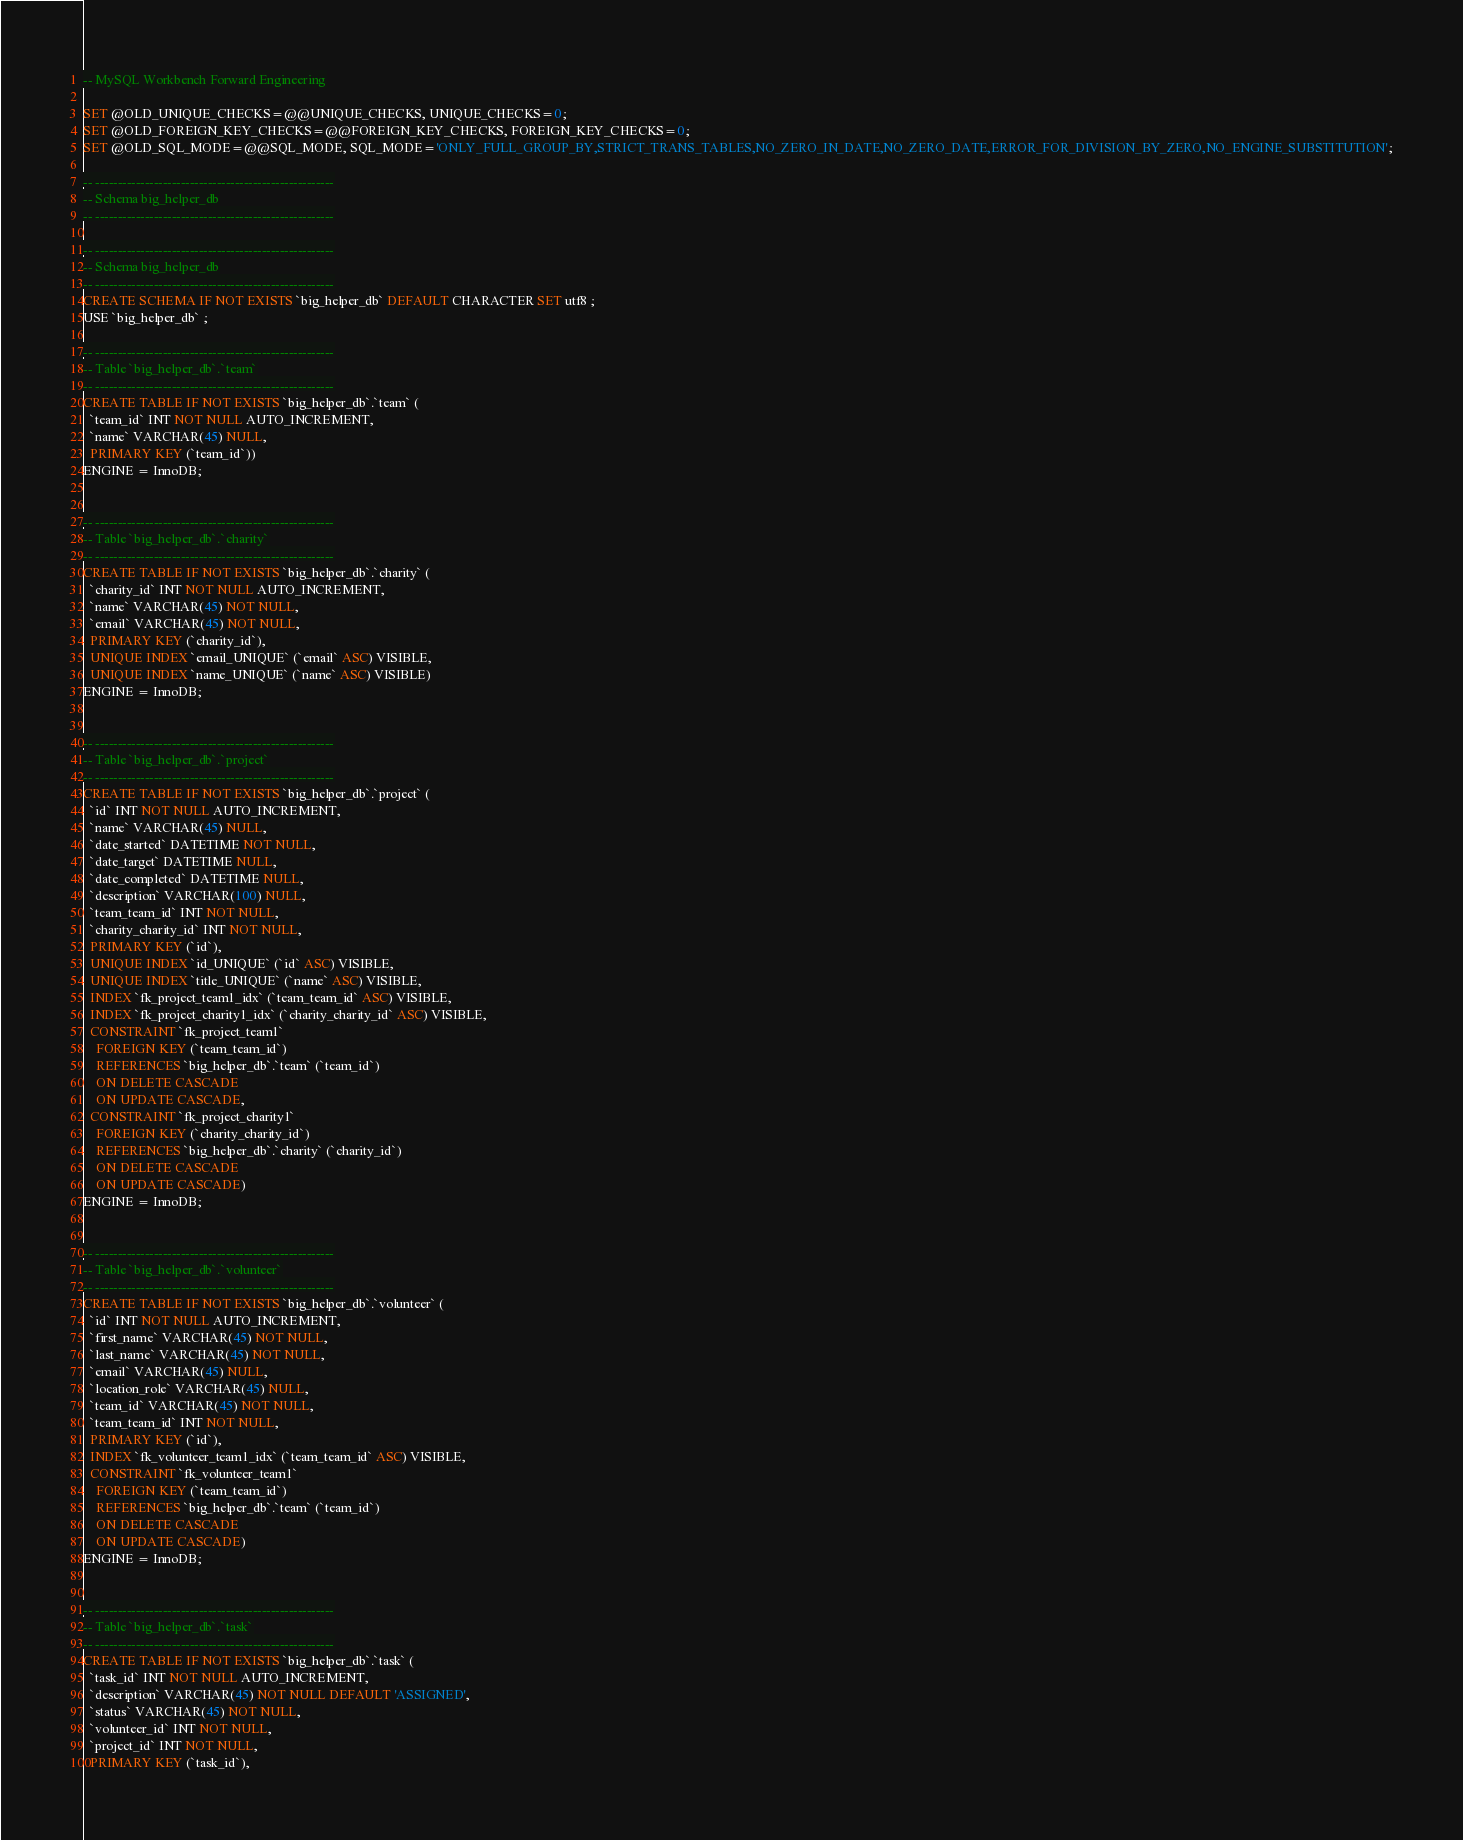<code> <loc_0><loc_0><loc_500><loc_500><_SQL_>-- MySQL Workbench Forward Engineering

SET @OLD_UNIQUE_CHECKS=@@UNIQUE_CHECKS, UNIQUE_CHECKS=0;
SET @OLD_FOREIGN_KEY_CHECKS=@@FOREIGN_KEY_CHECKS, FOREIGN_KEY_CHECKS=0;
SET @OLD_SQL_MODE=@@SQL_MODE, SQL_MODE='ONLY_FULL_GROUP_BY,STRICT_TRANS_TABLES,NO_ZERO_IN_DATE,NO_ZERO_DATE,ERROR_FOR_DIVISION_BY_ZERO,NO_ENGINE_SUBSTITUTION';

-- -----------------------------------------------------
-- Schema big_helper_db
-- -----------------------------------------------------

-- -----------------------------------------------------
-- Schema big_helper_db
-- -----------------------------------------------------
CREATE SCHEMA IF NOT EXISTS `big_helper_db` DEFAULT CHARACTER SET utf8 ;
USE `big_helper_db` ;

-- -----------------------------------------------------
-- Table `big_helper_db`.`team`
-- -----------------------------------------------------
CREATE TABLE IF NOT EXISTS `big_helper_db`.`team` (
  `team_id` INT NOT NULL AUTO_INCREMENT,
  `name` VARCHAR(45) NULL,
  PRIMARY KEY (`team_id`))
ENGINE = InnoDB;


-- -----------------------------------------------------
-- Table `big_helper_db`.`charity`
-- -----------------------------------------------------
CREATE TABLE IF NOT EXISTS `big_helper_db`.`charity` (
  `charity_id` INT NOT NULL AUTO_INCREMENT,
  `name` VARCHAR(45) NOT NULL,
  `email` VARCHAR(45) NOT NULL,
  PRIMARY KEY (`charity_id`),
  UNIQUE INDEX `email_UNIQUE` (`email` ASC) VISIBLE,
  UNIQUE INDEX `name_UNIQUE` (`name` ASC) VISIBLE)
ENGINE = InnoDB;


-- -----------------------------------------------------
-- Table `big_helper_db`.`project`
-- -----------------------------------------------------
CREATE TABLE IF NOT EXISTS `big_helper_db`.`project` (
  `id` INT NOT NULL AUTO_INCREMENT,
  `name` VARCHAR(45) NULL,
  `date_started` DATETIME NOT NULL,
  `date_target` DATETIME NULL,
  `date_completed` DATETIME NULL,
  `description` VARCHAR(100) NULL,
  `team_team_id` INT NOT NULL,
  `charity_charity_id` INT NOT NULL,
  PRIMARY KEY (`id`),
  UNIQUE INDEX `id_UNIQUE` (`id` ASC) VISIBLE,
  UNIQUE INDEX `title_UNIQUE` (`name` ASC) VISIBLE,
  INDEX `fk_project_team1_idx` (`team_team_id` ASC) VISIBLE,
  INDEX `fk_project_charity1_idx` (`charity_charity_id` ASC) VISIBLE,
  CONSTRAINT `fk_project_team1`
    FOREIGN KEY (`team_team_id`)
    REFERENCES `big_helper_db`.`team` (`team_id`)
    ON DELETE CASCADE
    ON UPDATE CASCADE,
  CONSTRAINT `fk_project_charity1`
    FOREIGN KEY (`charity_charity_id`)
    REFERENCES `big_helper_db`.`charity` (`charity_id`)
    ON DELETE CASCADE
    ON UPDATE CASCADE)
ENGINE = InnoDB;


-- -----------------------------------------------------
-- Table `big_helper_db`.`volunteer`
-- -----------------------------------------------------
CREATE TABLE IF NOT EXISTS `big_helper_db`.`volunteer` (
  `id` INT NOT NULL AUTO_INCREMENT,
  `first_name` VARCHAR(45) NOT NULL,
  `last_name` VARCHAR(45) NOT NULL,
  `email` VARCHAR(45) NULL,
  `location_role` VARCHAR(45) NULL,
  `team_id` VARCHAR(45) NOT NULL,
  `team_team_id` INT NOT NULL,
  PRIMARY KEY (`id`),
  INDEX `fk_volunteer_team1_idx` (`team_team_id` ASC) VISIBLE,
  CONSTRAINT `fk_volunteer_team1`
    FOREIGN KEY (`team_team_id`)
    REFERENCES `big_helper_db`.`team` (`team_id`)
    ON DELETE CASCADE
    ON UPDATE CASCADE)
ENGINE = InnoDB;


-- -----------------------------------------------------
-- Table `big_helper_db`.`task`
-- -----------------------------------------------------
CREATE TABLE IF NOT EXISTS `big_helper_db`.`task` (
  `task_id` INT NOT NULL AUTO_INCREMENT,
  `description` VARCHAR(45) NOT NULL DEFAULT 'ASSIGNED',
  `status` VARCHAR(45) NOT NULL,
  `volunteer_id` INT NOT NULL,
  `project_id` INT NOT NULL,
  PRIMARY KEY (`task_id`),</code> 